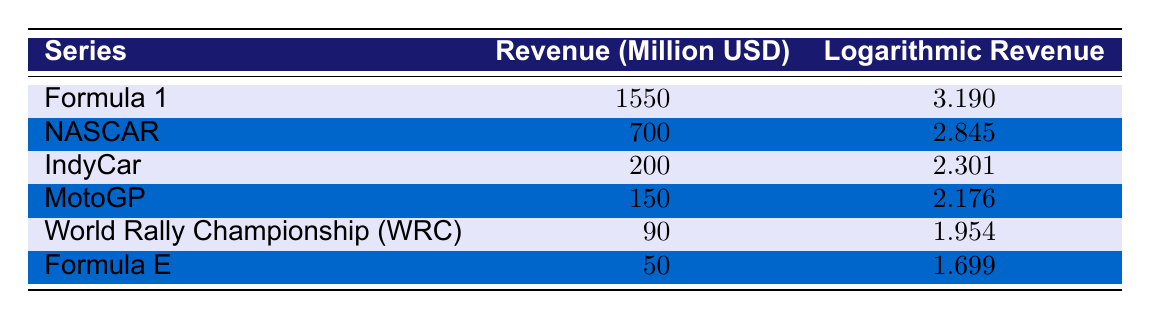What is the total revenue for Formula 1? The table shows that for Formula 1, the total revenue is listed under the "Revenue (Million USD)" column, which states 1550 million USD.
Answer: 1550 million USD Which motorsport series has the lowest logarithmic revenue? By looking at the "Logarithmic Revenue" column, the lowest value is 1.699 for Formula E, which is the smallest among all the listed series.
Answer: Formula E What is the difference in total revenue between NASCAR and IndyCar? NASCAR's total revenue is 700 million USD and IndyCar's is 200 million USD. The difference is calculated by subtracting IndyCar's revenue from NASCAR's: 700 - 200 = 500 million USD.
Answer: 500 million USD Is it true that MotoGP has a higher total revenue than World Rally Championship? Comparing the total revenues, MotoGP has 150 million USD while World Rally Championship has 90 million USD, thus confirming that MotoGP's revenue is indeed higher.
Answer: Yes What is the average logarithmic revenue of the motorsport series in the table? To find the average, sum the logarithmic revenues: (3.190 + 2.845 + 2.301 + 2.176 + 1.954 + 1.699) = 14.165. Then divide by the number of series (6): 14.165 / 6 = 2.361.
Answer: 2.361 Which two series have total revenues that sum up to over 2000 million USD? First, we examine combinations of the total revenues: Formula 1 (1550) + NASCAR (700) = 2250 million USD, which is over 2000 million. Additionally, Formula 1 combined with any other series will also exceed 2000 million.
Answer: Formula 1 and NASCAR What is the total revenue of all series combined? To find the total revenue, sum all the revenues: 1550 + 700 + 200 + 150 + 90 + 50 = 2740 million USD.
Answer: 2740 million USD Is the logarithmic revenue for IndyCar greater than that of MotoGP? IndyCar has a logarithmic revenue of 2.301, while MotoGP has 2.176. Since 2.301 is greater than 2.176, the statement is true.
Answer: Yes 